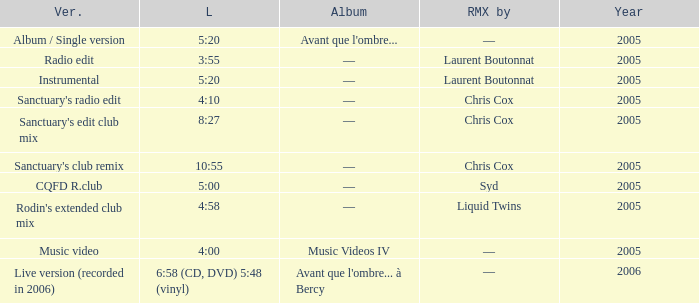What is the version shown for the Length of 5:20, and shows Remixed by —? Album / Single version. 